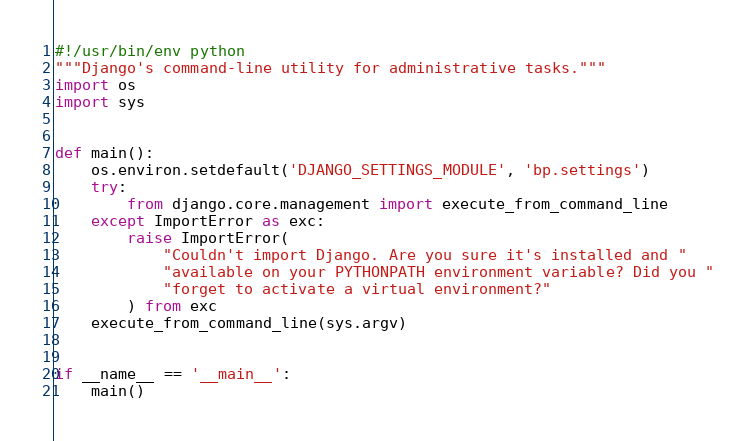Convert code to text. <code><loc_0><loc_0><loc_500><loc_500><_Python_>#!/usr/bin/env python
"""Django's command-line utility for administrative tasks."""
import os
import sys


def main():
    os.environ.setdefault('DJANGO_SETTINGS_MODULE', 'bp.settings')
    try:
        from django.core.management import execute_from_command_line
    except ImportError as exc:
        raise ImportError(
            "Couldn't import Django. Are you sure it's installed and "
            "available on your PYTHONPATH environment variable? Did you "
            "forget to activate a virtual environment?"
        ) from exc
    execute_from_command_line(sys.argv)


if __name__ == '__main__':
    main()
</code> 